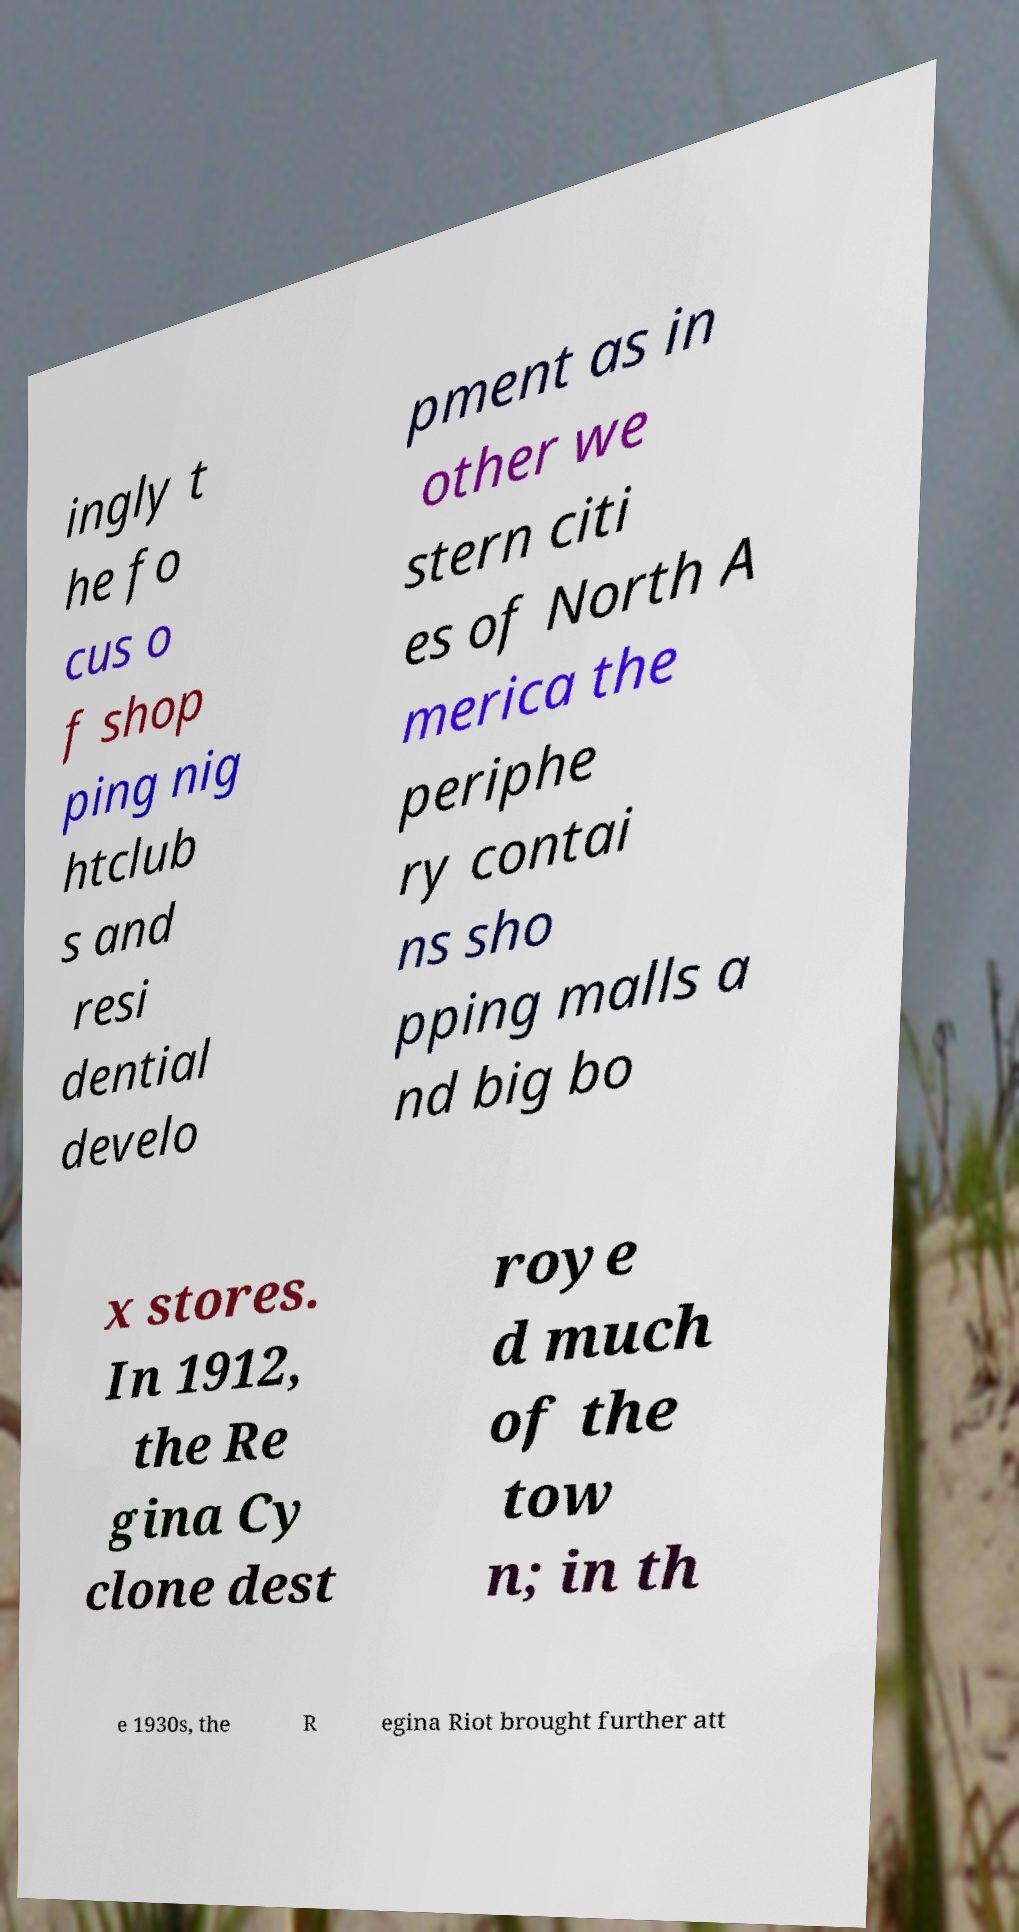Please identify and transcribe the text found in this image. ingly t he fo cus o f shop ping nig htclub s and resi dential develo pment as in other we stern citi es of North A merica the periphe ry contai ns sho pping malls a nd big bo x stores. In 1912, the Re gina Cy clone dest roye d much of the tow n; in th e 1930s, the R egina Riot brought further att 